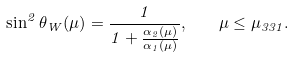Convert formula to latex. <formula><loc_0><loc_0><loc_500><loc_500>\sin ^ { 2 } \theta _ { W } ( \mu ) = \frac { 1 } { 1 + \frac { \alpha _ { 2 } ( \mu ) } { \alpha _ { 1 } ( \mu ) } } , \quad \mu \leq \mu _ { 3 3 1 } .</formula> 